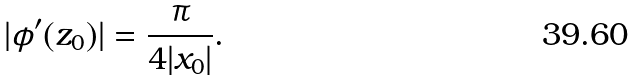Convert formula to latex. <formula><loc_0><loc_0><loc_500><loc_500>| \phi ^ { \prime } ( z _ { 0 } ) | = \frac { \pi } { 4 | x _ { 0 } | } .</formula> 